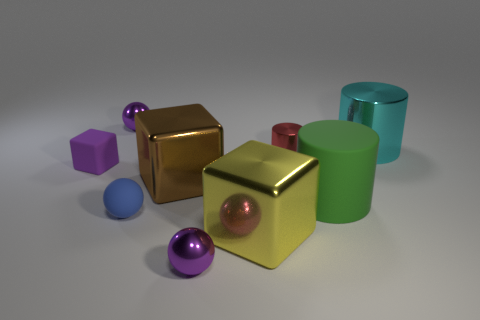Subtract all cyan blocks. Subtract all blue cylinders. How many blocks are left? 3 Subtract all balls. How many objects are left? 6 Subtract 1 purple blocks. How many objects are left? 8 Subtract all large brown things. Subtract all small gray balls. How many objects are left? 8 Add 5 large brown metal things. How many large brown metal things are left? 6 Add 1 small blue blocks. How many small blue blocks exist? 1 